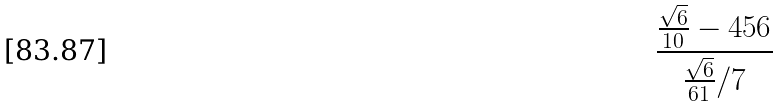<formula> <loc_0><loc_0><loc_500><loc_500>\frac { \frac { \sqrt { 6 } } { 1 0 } - 4 5 6 } { \frac { \sqrt { 6 } } { 6 1 } / 7 }</formula> 